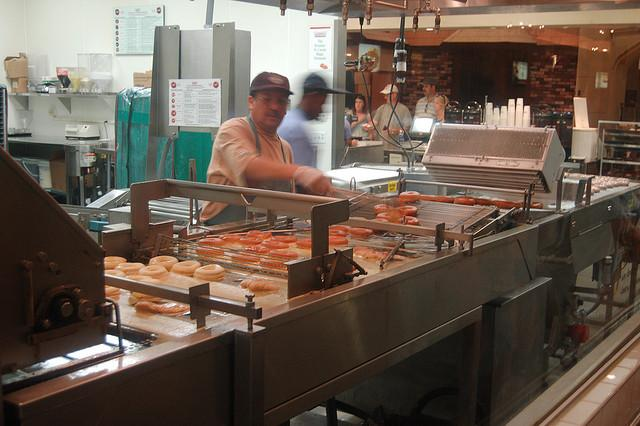What are the people in the background doing?

Choices:
A) serving customers
B) buy donuts
C) delivering drinks
D) delivering donuts buy donuts 